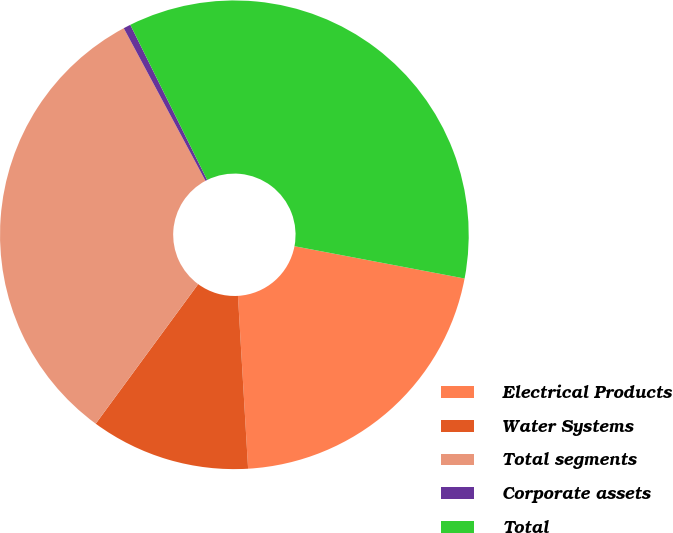Convert chart to OTSL. <chart><loc_0><loc_0><loc_500><loc_500><pie_chart><fcel>Electrical Products<fcel>Water Systems<fcel>Total segments<fcel>Corporate assets<fcel>Total<nl><fcel>21.08%<fcel>11.01%<fcel>32.1%<fcel>0.5%<fcel>35.31%<nl></chart> 